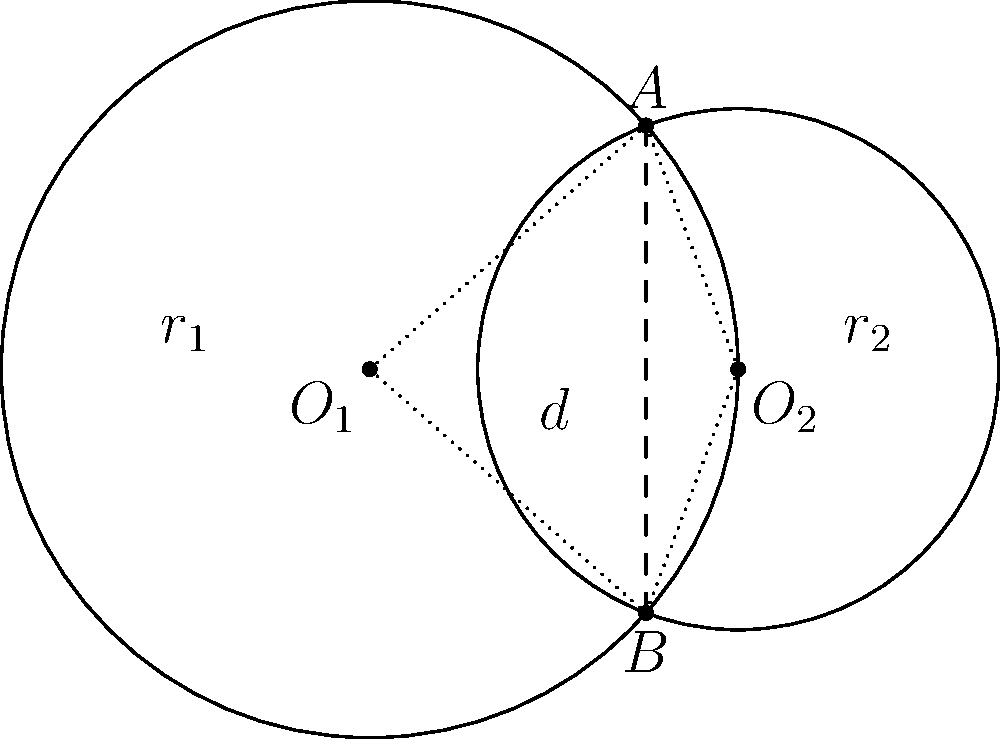In the diagram, two circles with centers $O_1$ and $O_2$ intersect at right angles. The radius of the larger circle is $r_1 = 1$ unit, and the distance between the centers is $d = 1$ unit. What is the length of the common chord $AB$? Let's approach this step-by-step:

1) In a right-angled intersection of circles, the radii to the point of intersection form a right-angled triangle with the line joining the centers.

2) Let the radius of the smaller circle be $r_2$. We can use the Pythagorean theorem:

   $$r_1^2 = d^2 + r_2^2$$

3) Substituting the known values:

   $$1^2 = 1^2 + r_2^2$$

4) Solving for $r_2$:

   $$r_2^2 = 1^2 - 1^2 = 0$$
   $$r_2 = \frac{\sqrt{2}}{2}$$

5) Now, the common chord $AB$ is perpendicular to the line joining the centers $O_1O_2$.

6) The triangle $AO_1O_2$ is right-angled at $O_2$. We can find $AO_2$ using the Pythagorean theorem:

   $$(AO_2)^2 = r_1^2 - (\frac{d}{2})^2 = 1^2 - (\frac{1}{2})^2 = \frac{3}{4}$$

7) Therefore, $AO_2 = \frac{\sqrt{3}}{2}$.

8) The length of $AB$ is twice this value:

   $$AB = 2 \cdot \frac{\sqrt{3}}{2} = \sqrt{3}$$

Thus, the length of the common chord $AB$ is $\sqrt{3}$ units.
Answer: $\sqrt{3}$ units 